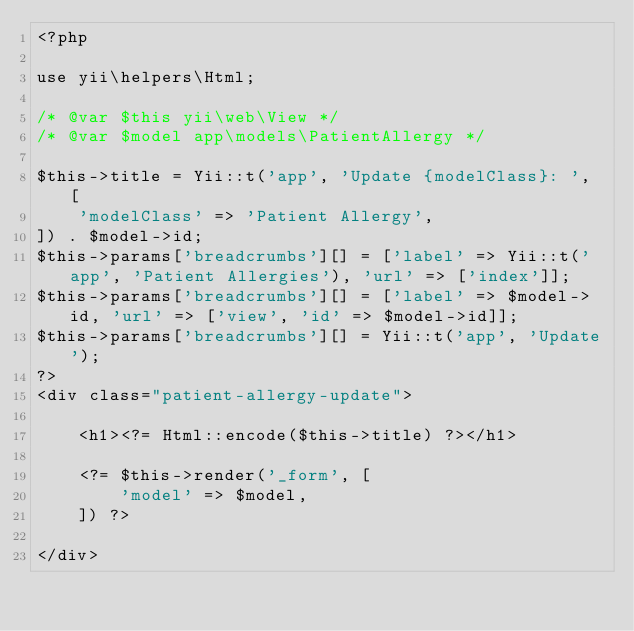<code> <loc_0><loc_0><loc_500><loc_500><_PHP_><?php

use yii\helpers\Html;

/* @var $this yii\web\View */
/* @var $model app\models\PatientAllergy */

$this->title = Yii::t('app', 'Update {modelClass}: ', [
    'modelClass' => 'Patient Allergy',
]) . $model->id;
$this->params['breadcrumbs'][] = ['label' => Yii::t('app', 'Patient Allergies'), 'url' => ['index']];
$this->params['breadcrumbs'][] = ['label' => $model->id, 'url' => ['view', 'id' => $model->id]];
$this->params['breadcrumbs'][] = Yii::t('app', 'Update');
?>
<div class="patient-allergy-update">

    <h1><?= Html::encode($this->title) ?></h1>

    <?= $this->render('_form', [
        'model' => $model,
    ]) ?>

</div>
</code> 